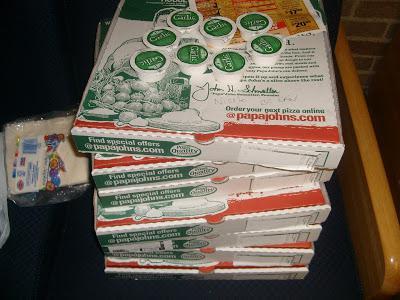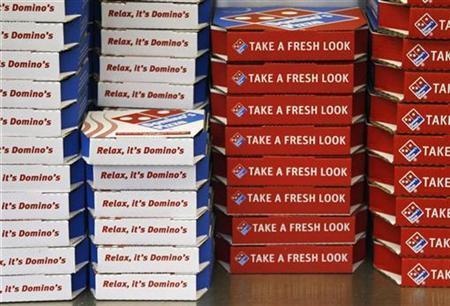The first image is the image on the left, the second image is the image on the right. Analyze the images presented: Is the assertion "There are at least five towers of pizza boxes." valid? Answer yes or no. Yes. The first image is the image on the left, the second image is the image on the right. Given the left and right images, does the statement "Both images contain pizza boxes." hold true? Answer yes or no. Yes. 